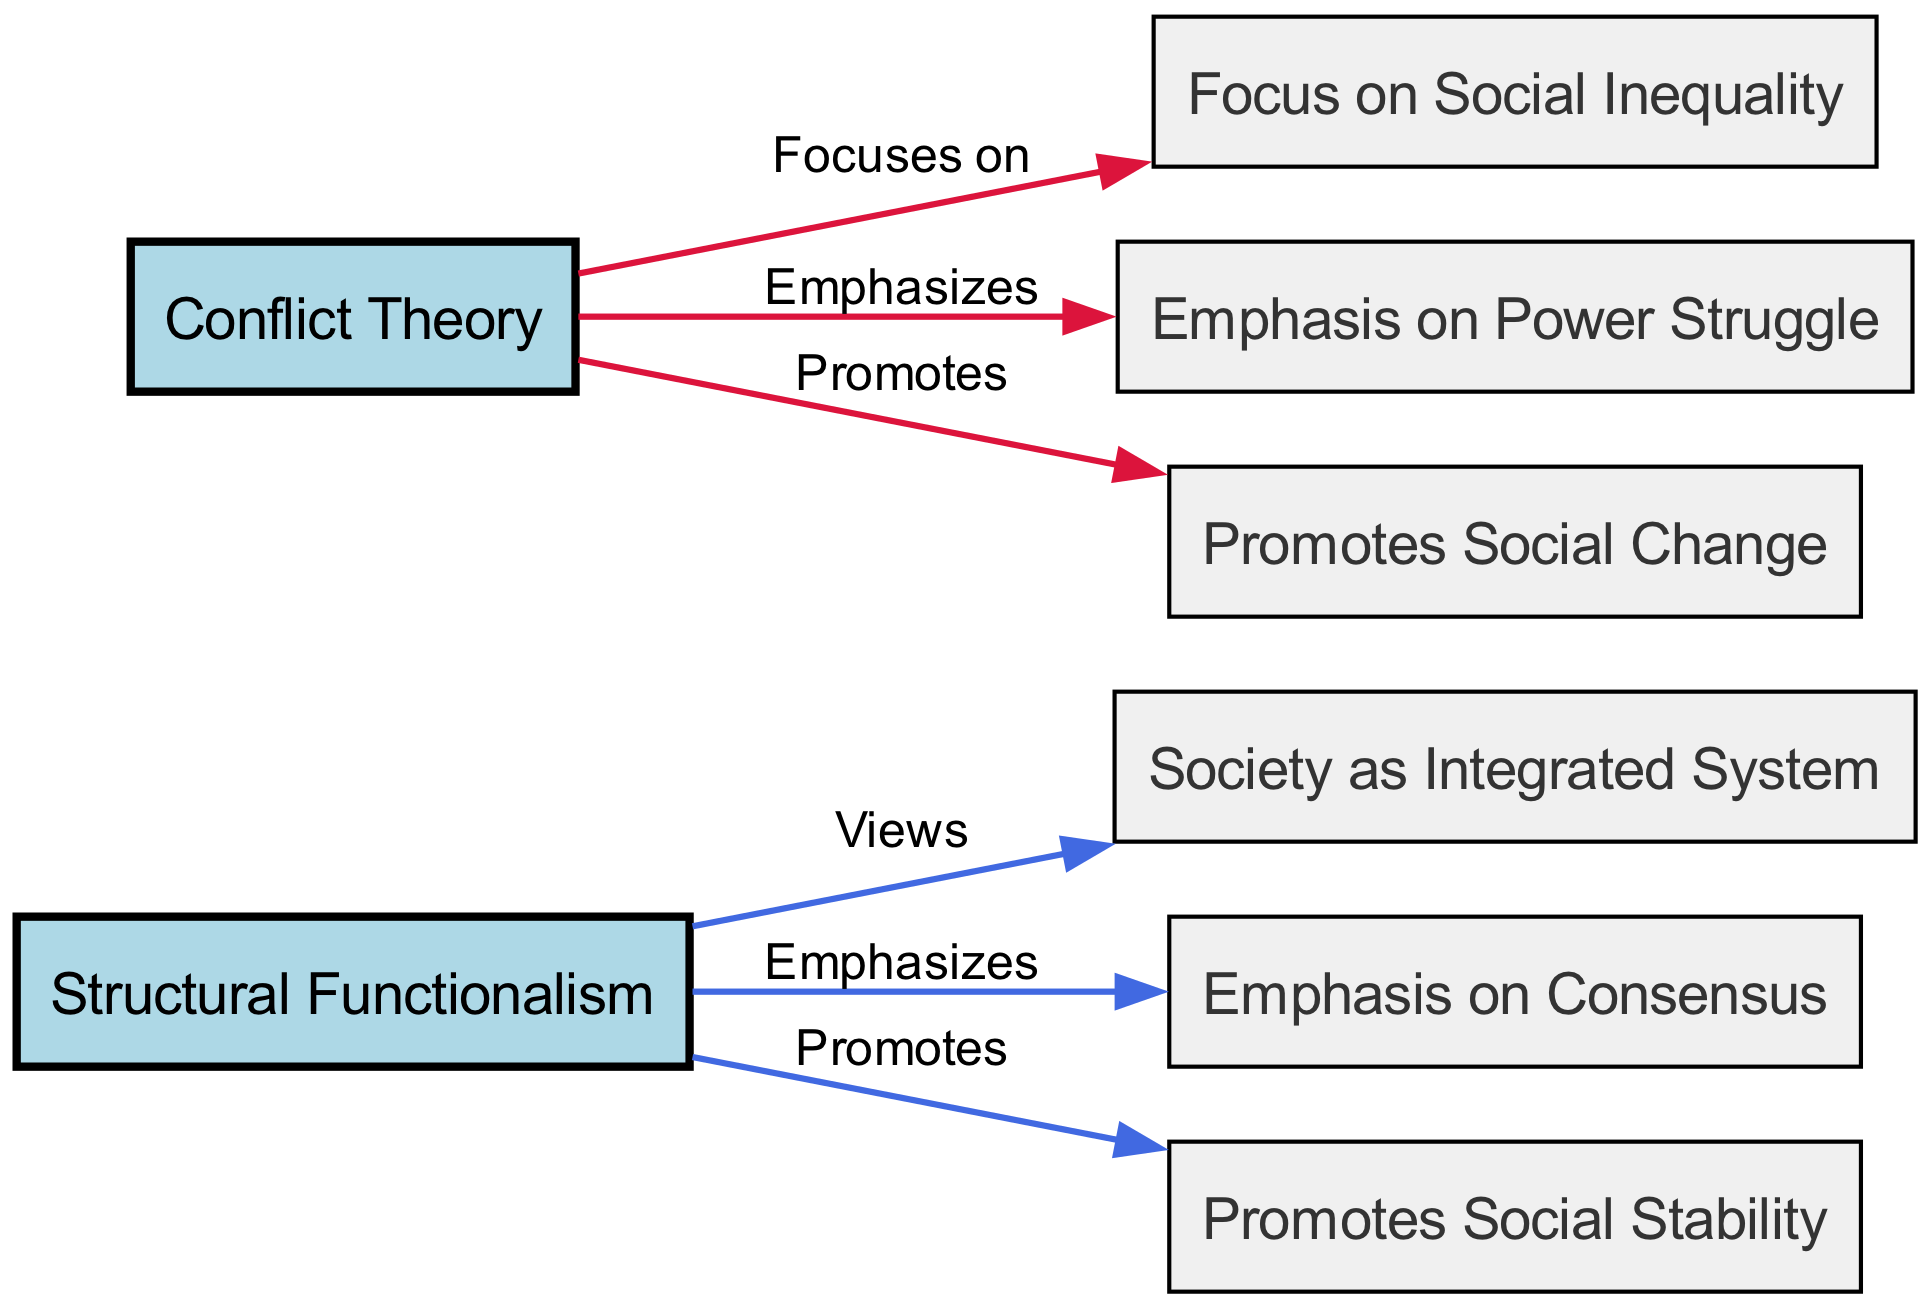What are the two main theories compared in this diagram? The diagram explicitly labels two main theories: "Structural Functionalism" and "Conflict Theory," which are represented as nodes.
Answer: Structural Functionalism, Conflict Theory How many nodes are present in the diagram? By counting the labeled nodes from the provided data, there is a total of eight distinct nodes, including the two main theories and their related concepts.
Answer: 8 What is the emphasis of Structural Functionalism? The diagram indicates that Structural Functionalism emphasizes consensus, which is a connecting edge labeled "Emphasizes" leading from Structural Functionalism to Consensus.
Answer: Consensus Which theory focuses on social inequality? The diagram shows that Conflict Theory focuses on social inequality, indicated by an edge labeled "Focuses on" leading from Conflict Theory to Social Inequality.
Answer: Social Inequality Which theory promotes social change? The diagram states that Conflict Theory promotes social change, with a directed edge labeled "Promotes" connecting Conflict Theory to Change.
Answer: Change What does Structural Functionalism view society as? According to the diagram, Structural Functionalism views society as an integrated system, represented by an edge labeled "Views" connecting Structural Functionalism to Society as Integrated System.
Answer: Integrated System Which theory has an emphasis on power struggle? The diagram clearly states that Conflict Theory has an emphasis on power struggle, illustrated by an edge labeled "Emphasizes" pointing from Conflict Theory to Power Struggle.
Answer: Power Struggle Which theory promotes social stability? The diagram specifies that Structural Functionalism promotes social stability, shown by a directed edge labeled "Promotes" from Structural Functionalism to Stability.
Answer: Social Stability How many edges are in the diagram? Counting the edges in the data shows that there are a total of six distinct edges, which represent the relationships between nodes.
Answer: 6 